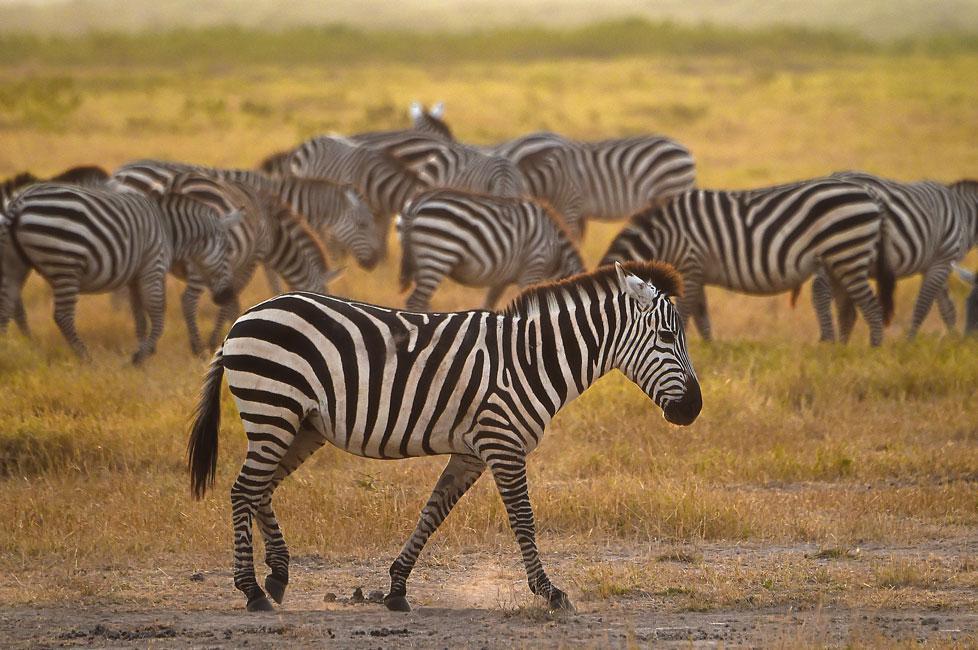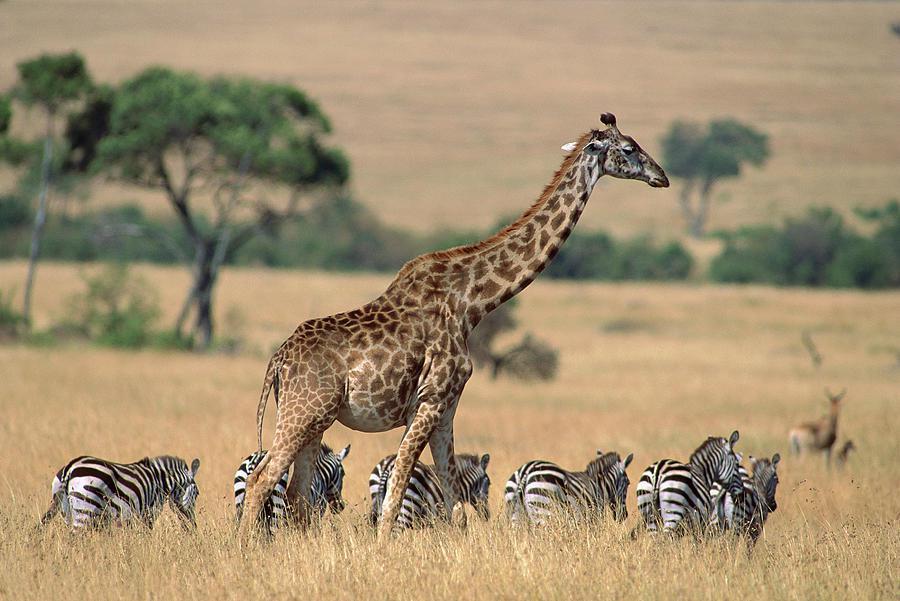The first image is the image on the left, the second image is the image on the right. Analyze the images presented: Is the assertion "The left image shows a giraffe and at least one other kind of mammal with zebra at a watering hole." valid? Answer yes or no. No. 